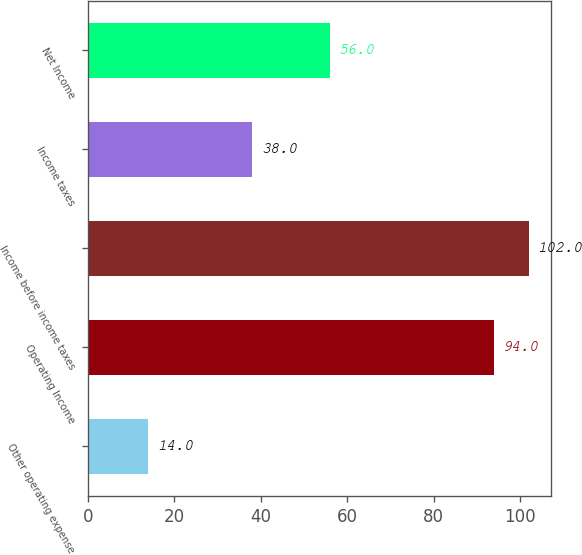Convert chart to OTSL. <chart><loc_0><loc_0><loc_500><loc_500><bar_chart><fcel>Other operating expense<fcel>Operating Income<fcel>Income before income taxes<fcel>Income taxes<fcel>Net Income<nl><fcel>14<fcel>94<fcel>102<fcel>38<fcel>56<nl></chart> 